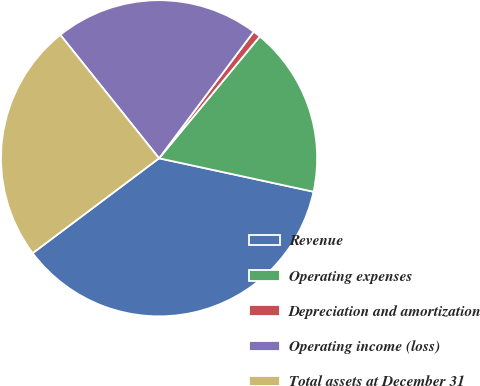<chart> <loc_0><loc_0><loc_500><loc_500><pie_chart><fcel>Revenue<fcel>Operating expenses<fcel>Depreciation and amortization<fcel>Operating income (loss)<fcel>Total assets at December 31<nl><fcel>36.36%<fcel>17.4%<fcel>0.78%<fcel>20.96%<fcel>24.51%<nl></chart> 